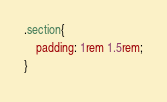<code> <loc_0><loc_0><loc_500><loc_500><_CSS_>.section{
    padding: 1rem 1.5rem;
}</code> 